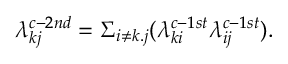<formula> <loc_0><loc_0><loc_500><loc_500>\lambda _ { k j } ^ { c - 2 n d } = \Sigma _ { i \neq k . j } ( \lambda _ { k i } ^ { c - 1 s t } \lambda _ { i j } ^ { c - 1 s t } ) .</formula> 